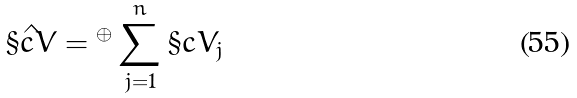<formula> <loc_0><loc_0><loc_500><loc_500>\hat { \S c { V } } = { ^ { \oplus } } \sum _ { j = 1 } ^ { n } \S c { V } _ { j }</formula> 